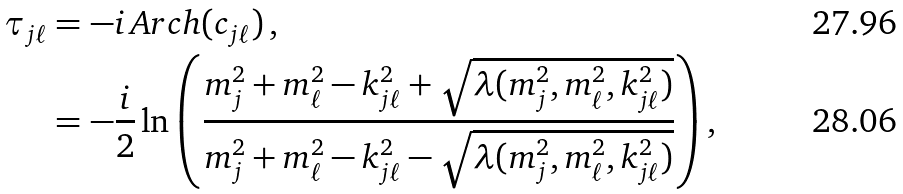<formula> <loc_0><loc_0><loc_500><loc_500>\tau _ { j \ell } & = - i \, A r c h ( c _ { j \ell } ) \, , \\ & = - \frac { i } { 2 } \ln \left ( \frac { m _ { j } ^ { 2 } + m _ { \ell } ^ { 2 } - k _ { j \ell } ^ { 2 } + \sqrt { \lambda ( m _ { j } ^ { 2 } , m _ { \ell } ^ { 2 } , k _ { j \ell } ^ { 2 } ) } } { m _ { j } ^ { 2 } + m _ { \ell } ^ { 2 } - k _ { j \ell } ^ { 2 } - \sqrt { \lambda ( m _ { j } ^ { 2 } , m _ { \ell } ^ { 2 } , k _ { j \ell } ^ { 2 } ) } } \right ) ,</formula> 